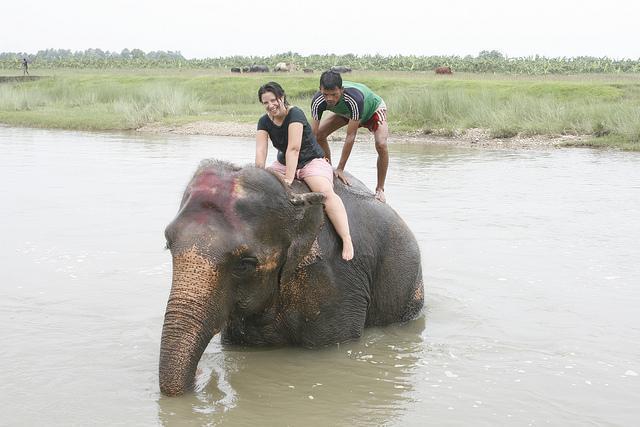How many people on the elephant?
Give a very brief answer. 2. How many people are there?
Give a very brief answer. 2. 